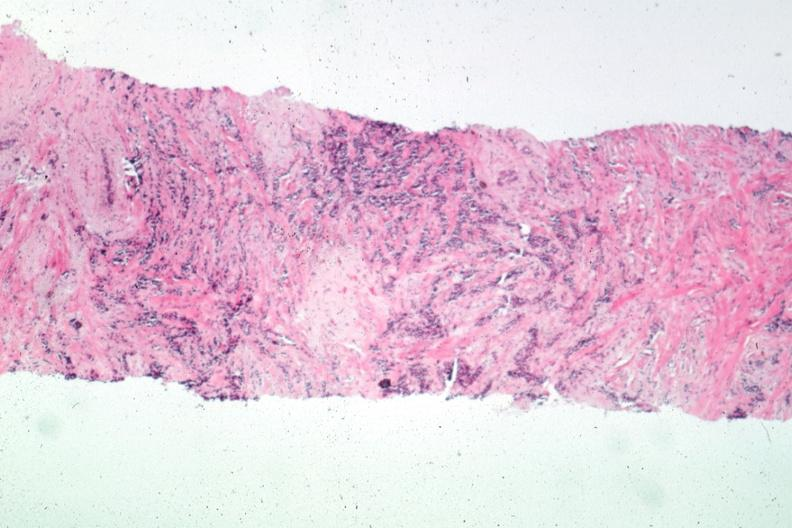what does this image show?
Answer the question using a single word or phrase. Needle biopsy with obvious carcinoma 